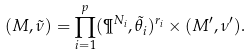<formula> <loc_0><loc_0><loc_500><loc_500>( M , \tilde { \nu } ) = \prod _ { i = 1 } ^ { p } ( \P ^ { N _ { i } } , \tilde { \theta } _ { i } ) ^ { r _ { i } } \times ( M ^ { \prime } , \nu ^ { \prime } ) .</formula> 